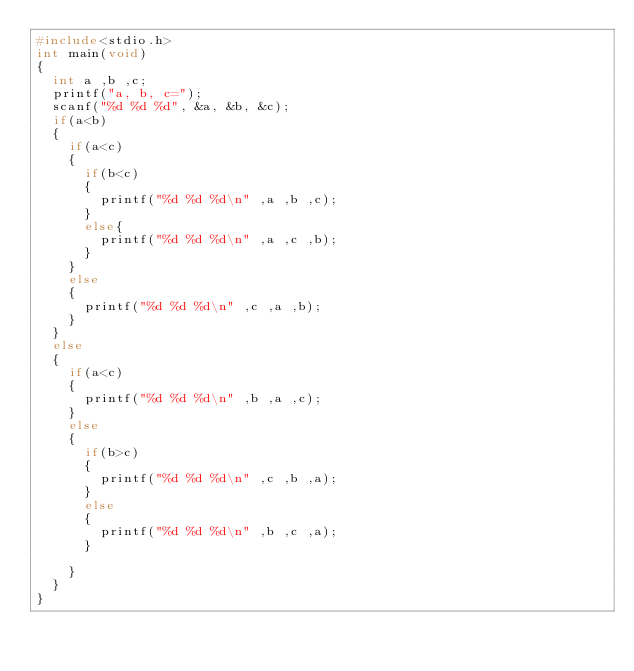Convert code to text. <code><loc_0><loc_0><loc_500><loc_500><_C_>#include<stdio.h>
int main(void)
{
	int a ,b ,c;
	printf("a, b, c=");
	scanf("%d %d %d", &a, &b, &c);
	if(a<b)
	{
		if(a<c)
		{
			if(b<c)
			{
				printf("%d %d %d\n" ,a ,b ,c);
			}
			else{
				printf("%d %d %d\n" ,a ,c ,b);
			}
		}
		else
		{
			printf("%d %d %d\n" ,c ,a ,b);
		}
	}
	else
	{
		if(a<c)
		{
			printf("%d %d %d\n" ,b ,a ,c);
		}
		else
		{
			if(b>c)
			{
				printf("%d %d %d\n" ,c ,b ,a);
			}
			else
			{
				printf("%d %d %d\n" ,b ,c ,a);
			}

		}
	}
}</code> 